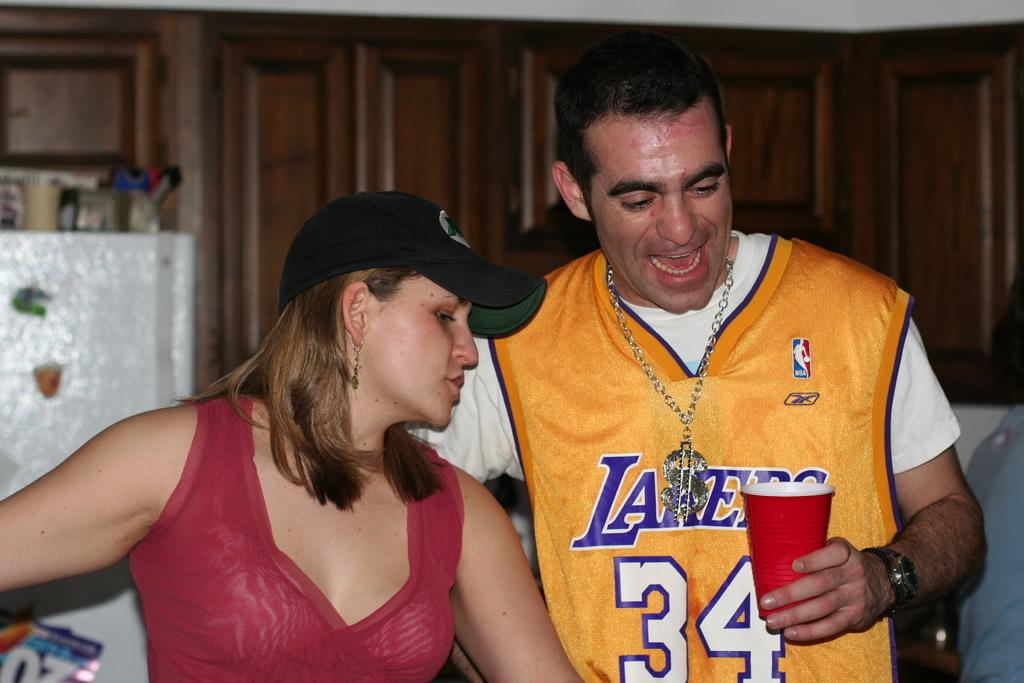<image>
Offer a succinct explanation of the picture presented. A man is in a Lakers jersey with the number 34 on the front. 